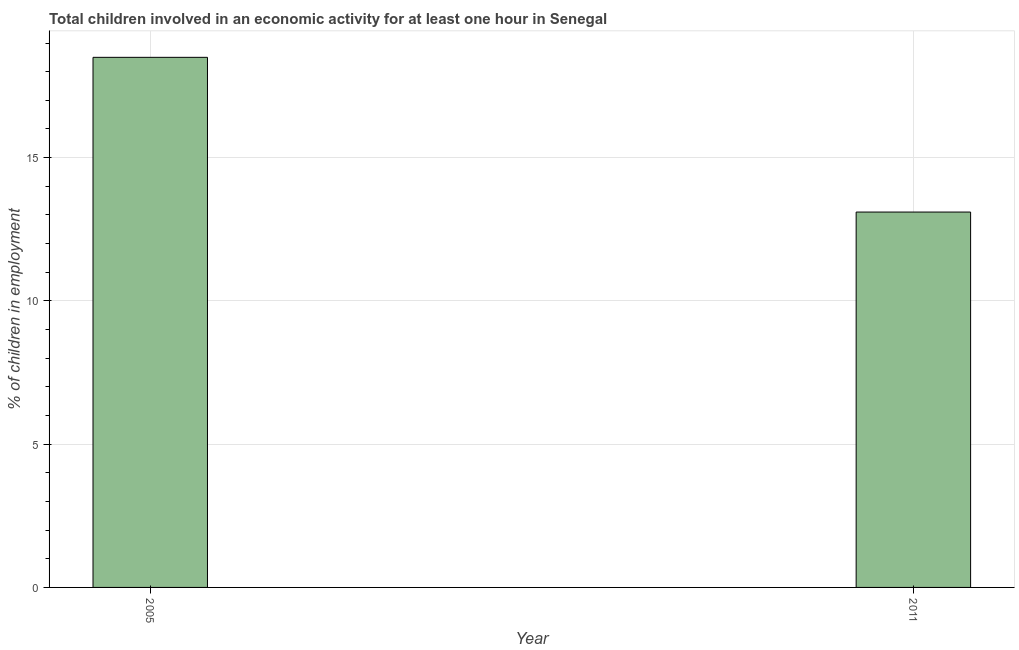Does the graph contain any zero values?
Ensure brevity in your answer.  No. Does the graph contain grids?
Your answer should be compact. Yes. What is the title of the graph?
Provide a short and direct response. Total children involved in an economic activity for at least one hour in Senegal. What is the label or title of the Y-axis?
Offer a terse response. % of children in employment. Across all years, what is the minimum percentage of children in employment?
Your answer should be very brief. 13.1. In which year was the percentage of children in employment minimum?
Provide a succinct answer. 2011. What is the sum of the percentage of children in employment?
Your response must be concise. 31.6. What is the difference between the percentage of children in employment in 2005 and 2011?
Offer a terse response. 5.4. What is the average percentage of children in employment per year?
Keep it short and to the point. 15.8. What is the median percentage of children in employment?
Keep it short and to the point. 15.8. In how many years, is the percentage of children in employment greater than 13 %?
Provide a succinct answer. 2. Do a majority of the years between 2011 and 2005 (inclusive) have percentage of children in employment greater than 7 %?
Ensure brevity in your answer.  No. What is the ratio of the percentage of children in employment in 2005 to that in 2011?
Provide a short and direct response. 1.41. Is the percentage of children in employment in 2005 less than that in 2011?
Offer a terse response. No. Are all the bars in the graph horizontal?
Ensure brevity in your answer.  No. What is the difference between two consecutive major ticks on the Y-axis?
Provide a short and direct response. 5. Are the values on the major ticks of Y-axis written in scientific E-notation?
Provide a succinct answer. No. What is the % of children in employment in 2011?
Provide a short and direct response. 13.1. What is the ratio of the % of children in employment in 2005 to that in 2011?
Your answer should be very brief. 1.41. 